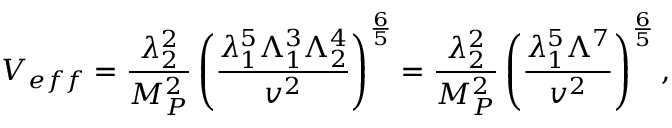Convert formula to latex. <formula><loc_0><loc_0><loc_500><loc_500>V _ { e f f } = \frac { \lambda _ { 2 } ^ { 2 } } { M _ { P } ^ { 2 } } \left ( \frac { \lambda _ { 1 } ^ { 5 } \Lambda _ { 1 } ^ { 3 } \Lambda _ { 2 } ^ { 4 } } { v ^ { 2 } } \right ) ^ { \frac { 6 } { 5 } } = \frac { \lambda _ { 2 } ^ { 2 } } { M _ { P } ^ { 2 } } \left ( \frac { \lambda _ { 1 } ^ { 5 } \Lambda ^ { 7 } } { v ^ { 2 } } \right ) ^ { \frac { 6 } { 5 } } ,</formula> 